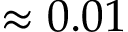Convert formula to latex. <formula><loc_0><loc_0><loc_500><loc_500>\approx 0 . 0 1</formula> 